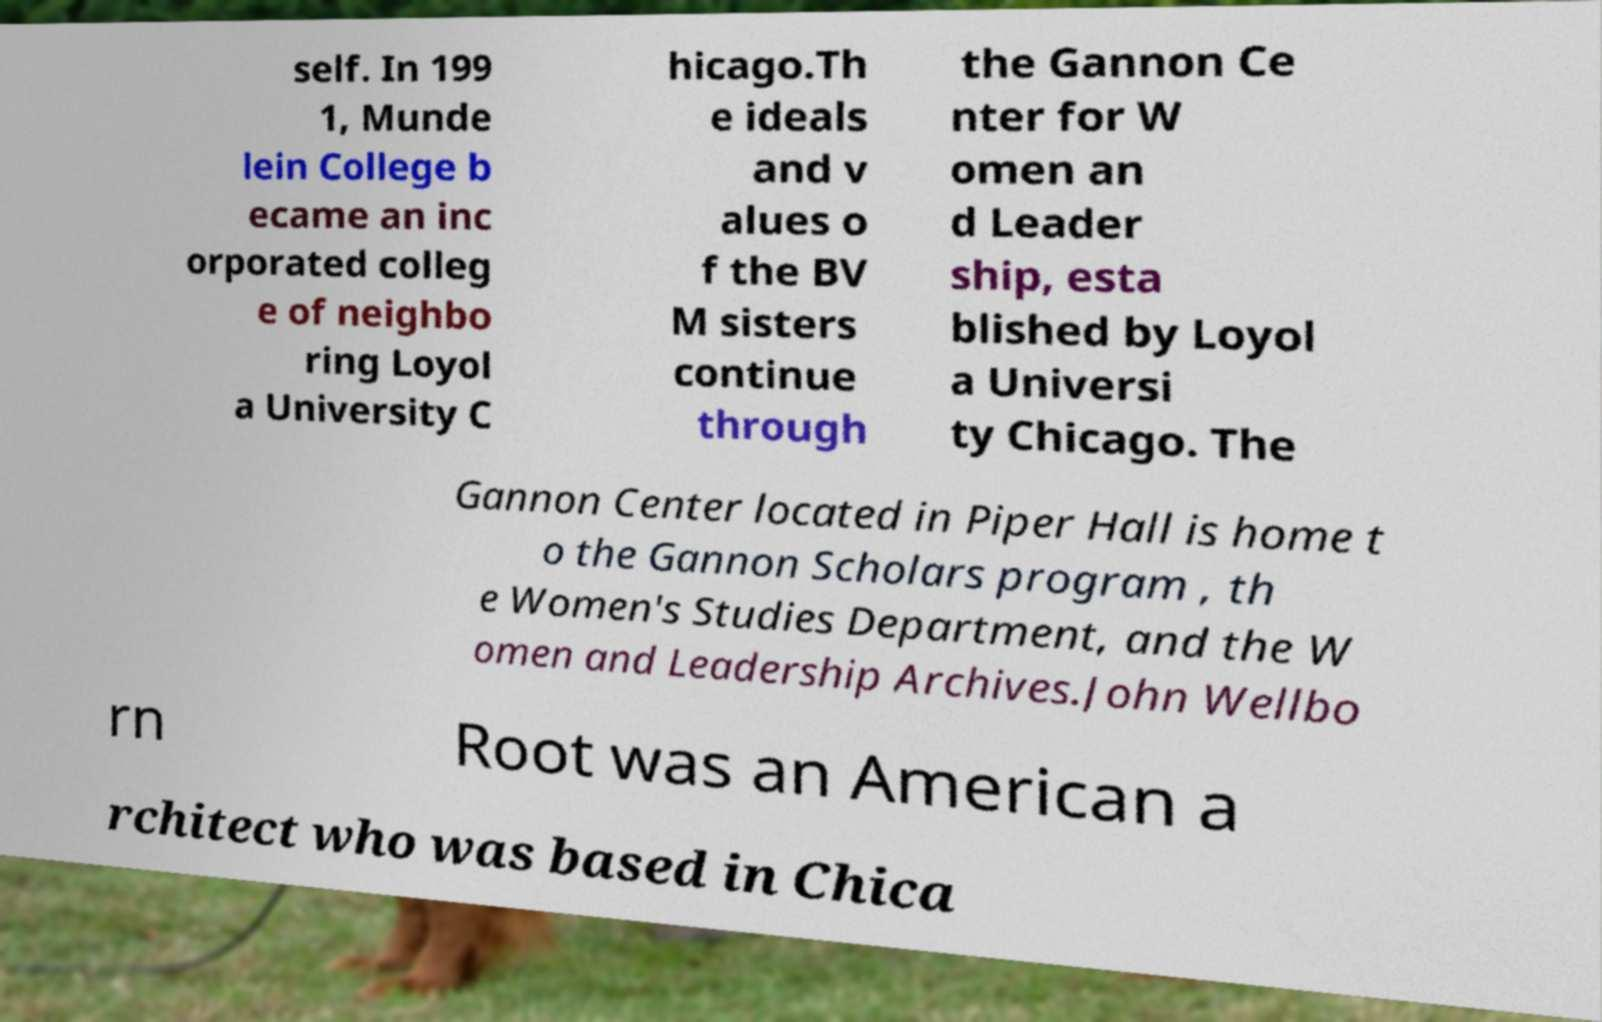Please read and relay the text visible in this image. What does it say? self. In 199 1, Munde lein College b ecame an inc orporated colleg e of neighbo ring Loyol a University C hicago.Th e ideals and v alues o f the BV M sisters continue through the Gannon Ce nter for W omen an d Leader ship, esta blished by Loyol a Universi ty Chicago. The Gannon Center located in Piper Hall is home t o the Gannon Scholars program , th e Women's Studies Department, and the W omen and Leadership Archives.John Wellbo rn Root was an American a rchitect who was based in Chica 